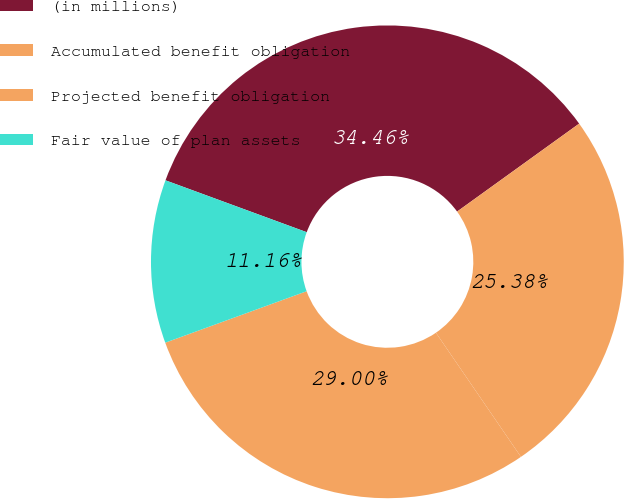<chart> <loc_0><loc_0><loc_500><loc_500><pie_chart><fcel>(in millions)<fcel>Accumulated benefit obligation<fcel>Projected benefit obligation<fcel>Fair value of plan assets<nl><fcel>34.46%<fcel>25.38%<fcel>29.0%<fcel>11.16%<nl></chart> 